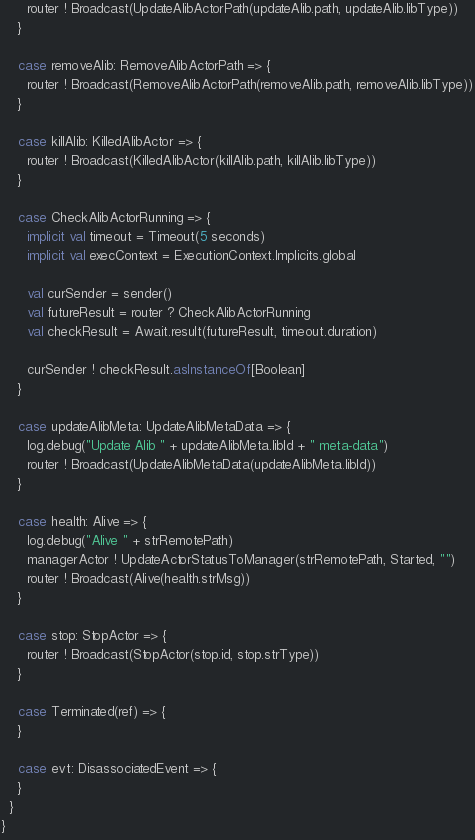<code> <loc_0><loc_0><loc_500><loc_500><_Scala_>      router ! Broadcast(UpdateAlibActorPath(updateAlib.path, updateAlib.libType))
    }

    case removeAlib: RemoveAlibActorPath => {
      router ! Broadcast(RemoveAlibActorPath(removeAlib.path, removeAlib.libType))
    }

    case killAlib: KilledAlibActor => {
      router ! Broadcast(KilledAlibActor(killAlib.path, killAlib.libType))
    }

    case CheckAlibActorRunning => {
      implicit val timeout = Timeout(5 seconds)
      implicit val execContext = ExecutionContext.Implicits.global

      val curSender = sender()
      val futureResult = router ? CheckAlibActorRunning
      val checkResult = Await.result(futureResult, timeout.duration)

      curSender ! checkResult.asInstanceOf[Boolean]
    }

    case updateAlibMeta: UpdateAlibMetaData => {
      log.debug("Update Alib " + updateAlibMeta.libId + " meta-data")
      router ! Broadcast(UpdateAlibMetaData(updateAlibMeta.libId))
    }

    case health: Alive => {
      log.debug("Alive " + strRemotePath)
      managerActor ! UpdateActorStatusToManager(strRemotePath, Started, "")
      router ! Broadcast(Alive(health.strMsg))
    }

    case stop: StopActor => {
      router ! Broadcast(StopActor(stop.id, stop.strType))
    }

    case Terminated(ref) => {
    }

    case evt: DisassociatedEvent => {
    }
  }
}
</code> 